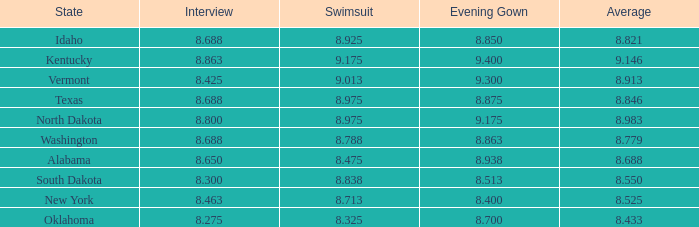513? None. 